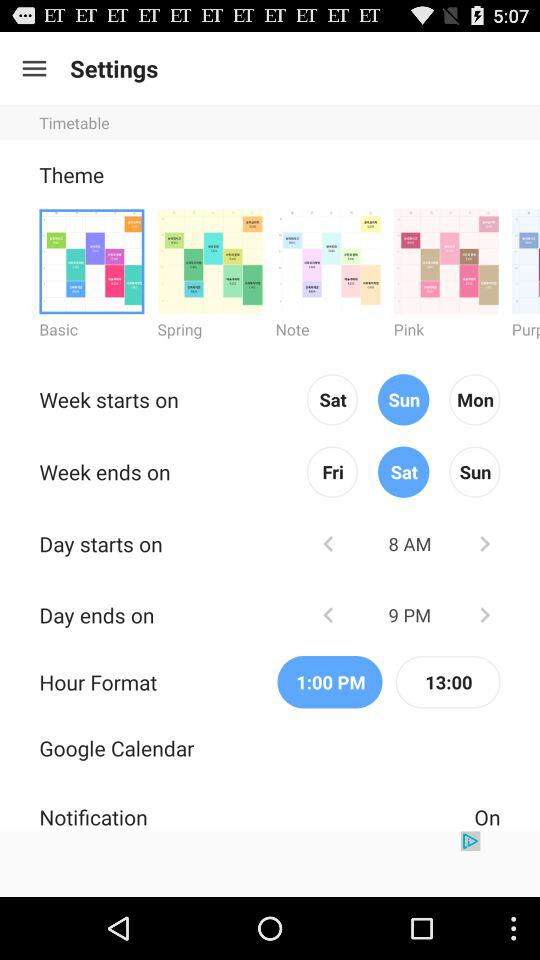At what time will the day end? The day will end at 9 PM. 